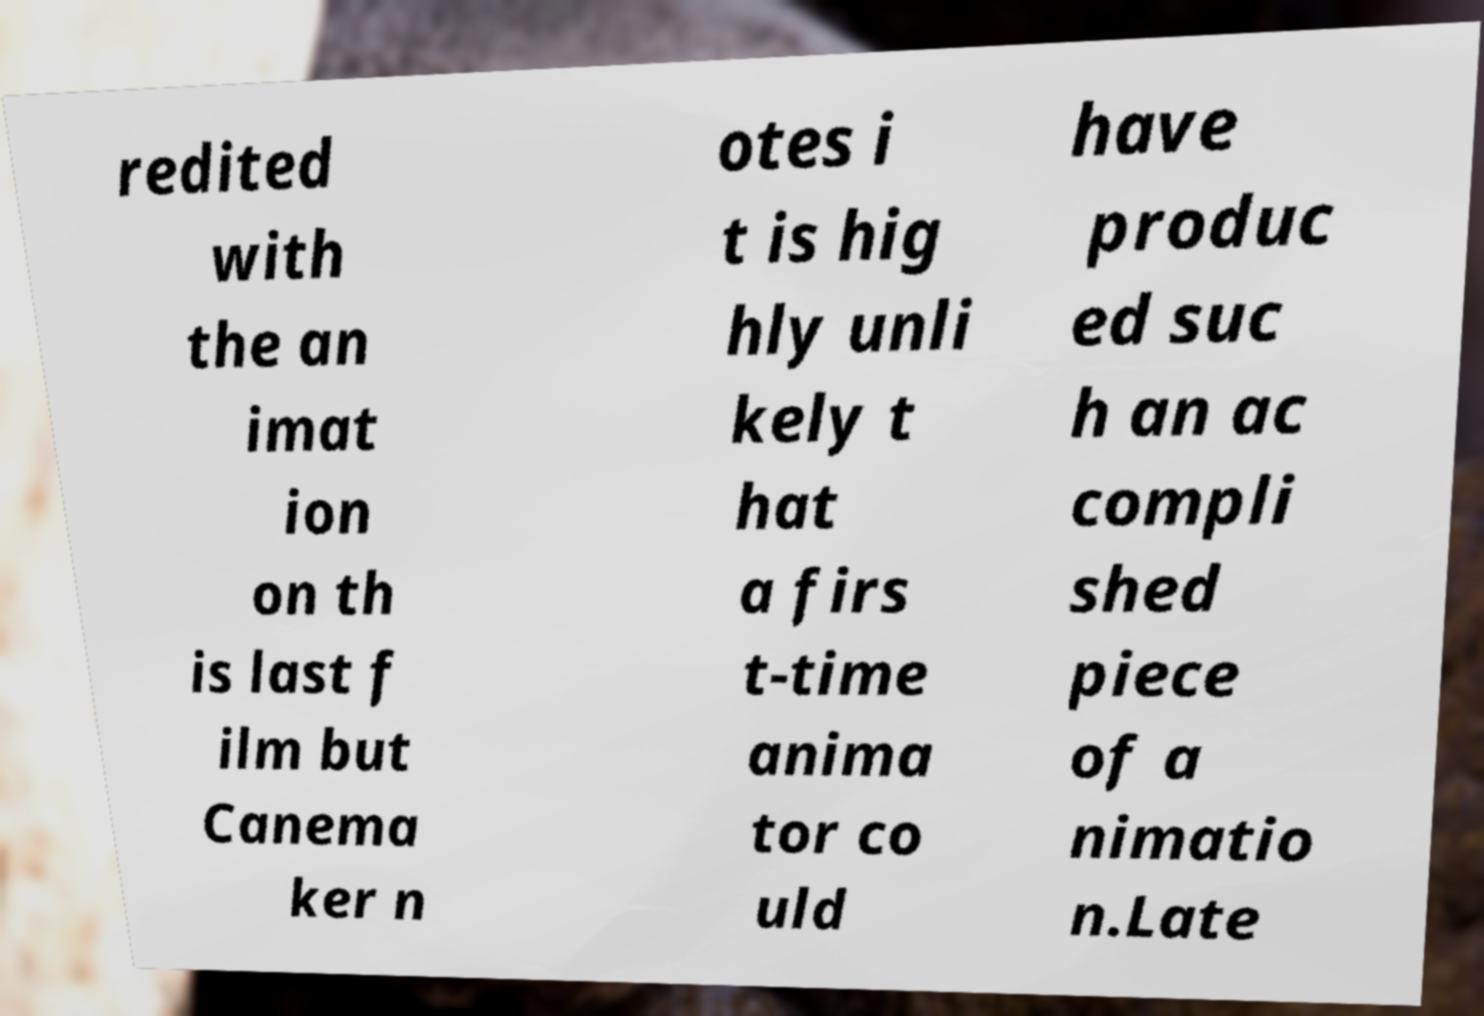For documentation purposes, I need the text within this image transcribed. Could you provide that? redited with the an imat ion on th is last f ilm but Canema ker n otes i t is hig hly unli kely t hat a firs t-time anima tor co uld have produc ed suc h an ac compli shed piece of a nimatio n.Late 